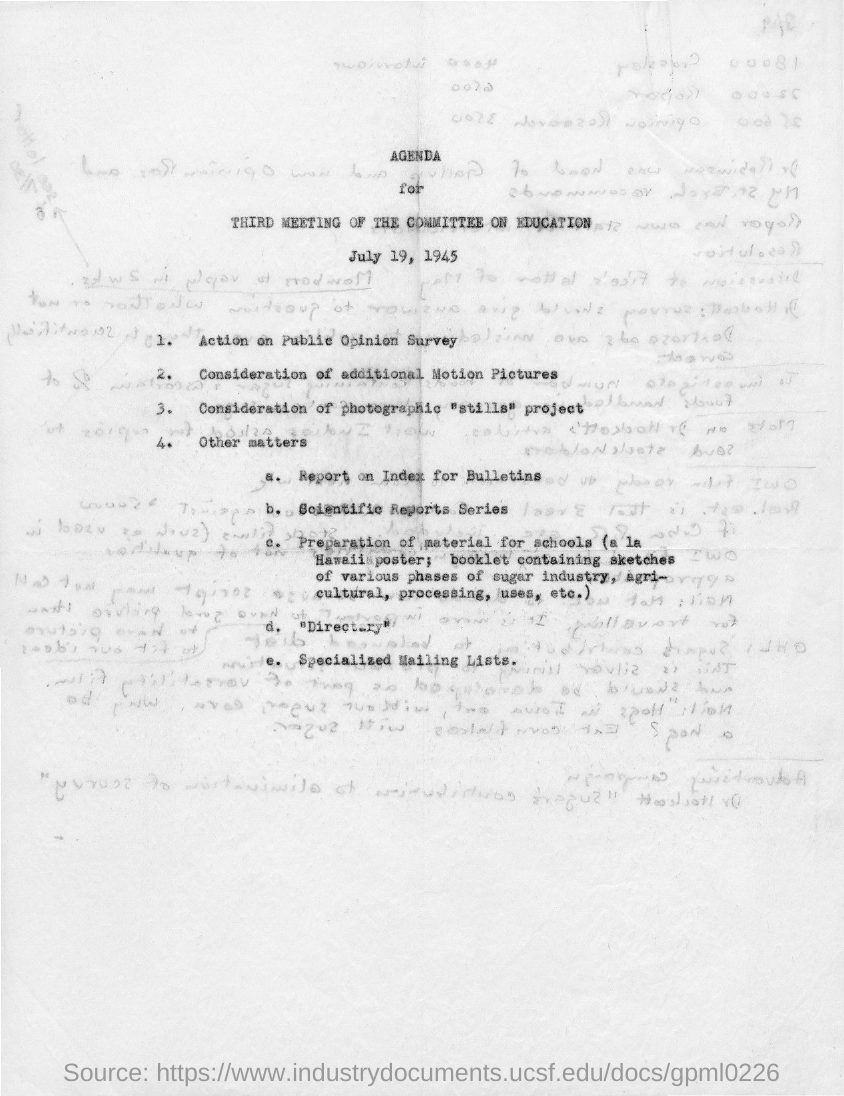Specify some key components in this picture. The title of the document is Agenda. 